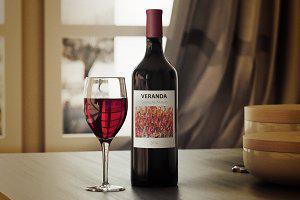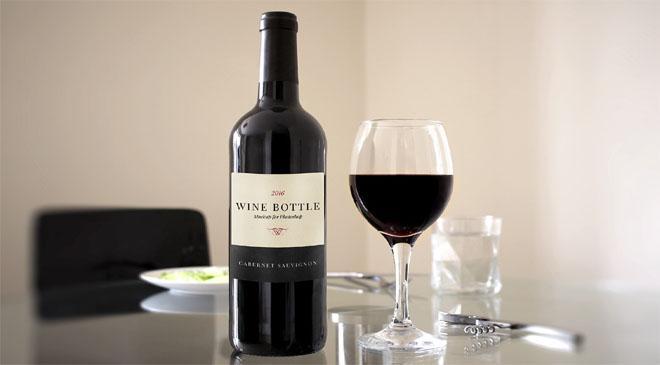The first image is the image on the left, the second image is the image on the right. Given the left and right images, does the statement "There is more than one wine glass in one of the images." hold true? Answer yes or no. No. 